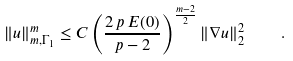<formula> <loc_0><loc_0><loc_500><loc_500>\| u \| _ { m , \Gamma _ { 1 } } ^ { m } \leq C \left ( \frac { 2 \, p \, E ( 0 ) } { p - 2 } \right ) ^ { \frac { m - 2 } { 2 } } \| \nabla u \| _ { 2 } ^ { 2 } \quad .</formula> 